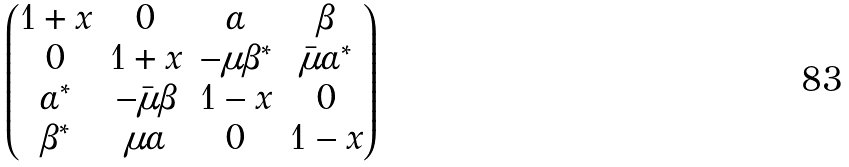<formula> <loc_0><loc_0><loc_500><loc_500>\begin{pmatrix} 1 + x & 0 & \alpha & \beta \\ 0 & 1 + x & - \mu \beta ^ { * } & \bar { \mu } \alpha ^ { * } \\ \alpha ^ { * } & - \bar { \mu } \beta & 1 - x & 0 \\ \beta ^ { * } & \mu \alpha & 0 & 1 - x \end{pmatrix}</formula> 